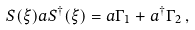<formula> <loc_0><loc_0><loc_500><loc_500>S ( \xi ) a S ^ { \dagger } ( \xi ) = a \Gamma _ { 1 } + a ^ { \dagger } \Gamma _ { 2 } \, ,</formula> 